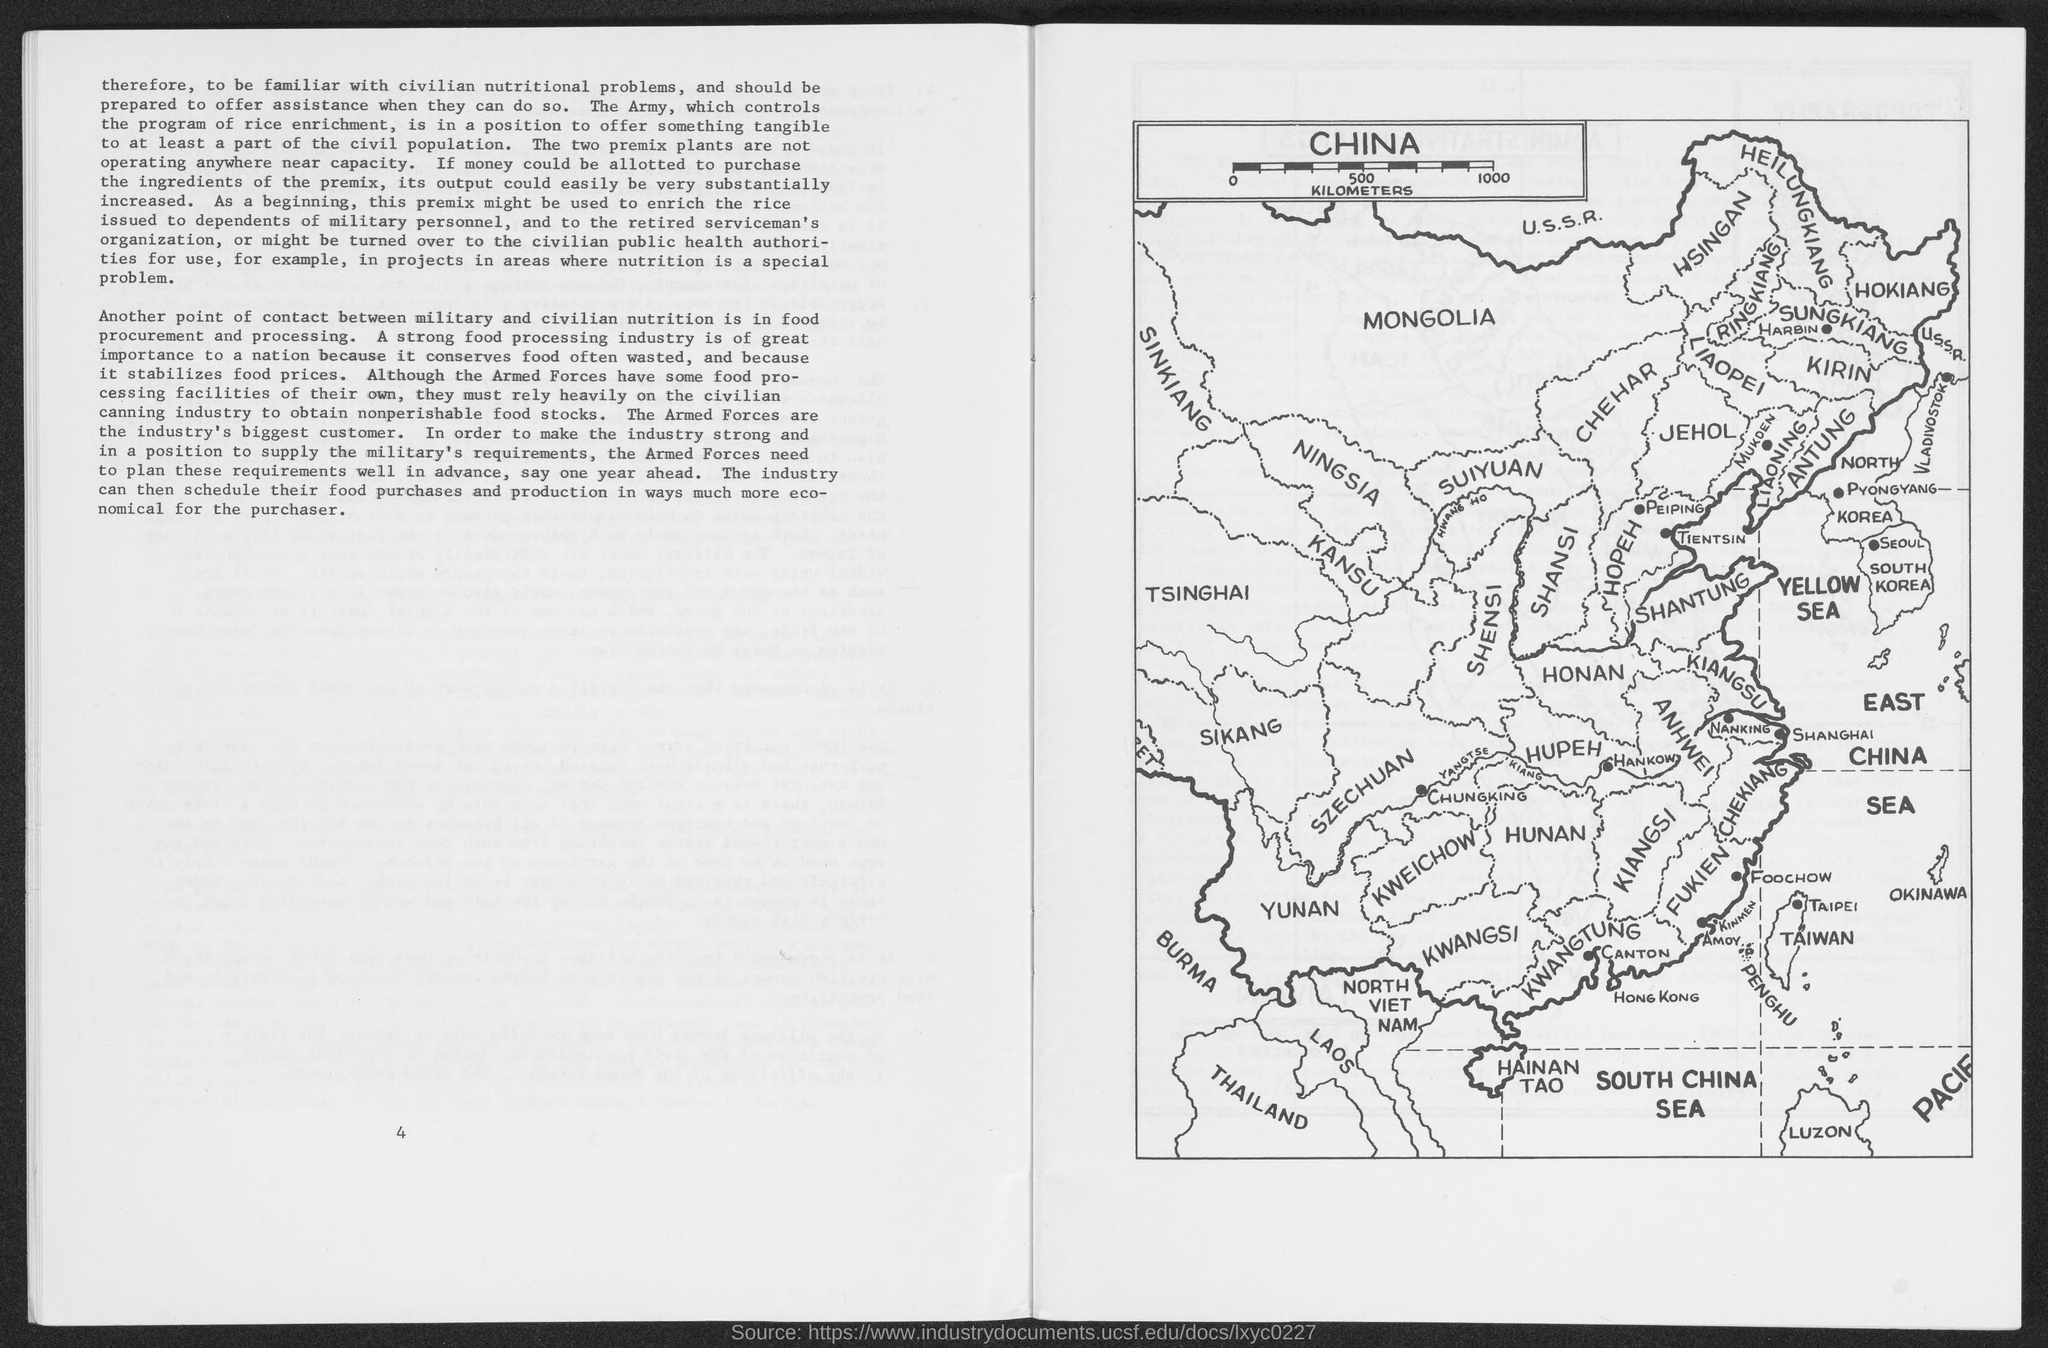What is written in biggest size font in the top left corner rectangle box in the map ?
Offer a terse response. China. Who are the industrys biggest customer ?
Make the answer very short. Armed Forces. What is written in smaller size font letters between SOUTH CHINA SEA and PACIF in the right bottom corner of map?
Provide a short and direct response. LUZON. What is written in bold and bigger size font just below the word TAIPEI in map?
Your answer should be compact. TAIWAN. What is written in capital letters just left side to the word SUIYAUAN in map
Ensure brevity in your answer.  NINGSIA. 